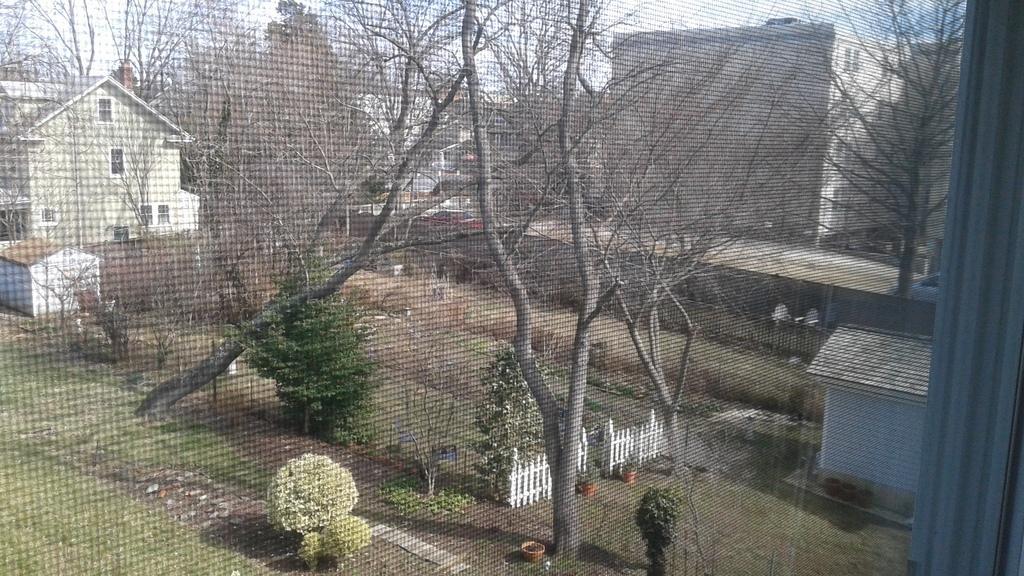In one or two sentences, can you explain what this image depicts? In this image we can see sky, trees, bushes, wooden fence, houseplants, sheds and iron grills through the mesh of a window. 